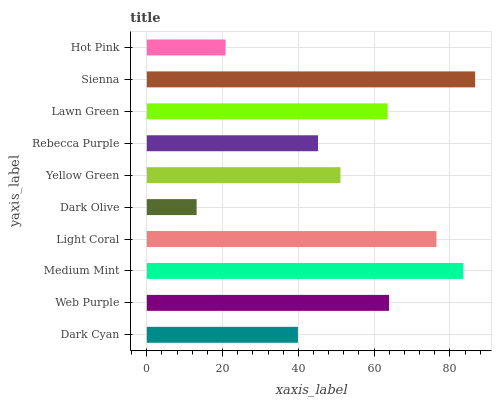Is Dark Olive the minimum?
Answer yes or no. Yes. Is Sienna the maximum?
Answer yes or no. Yes. Is Web Purple the minimum?
Answer yes or no. No. Is Web Purple the maximum?
Answer yes or no. No. Is Web Purple greater than Dark Cyan?
Answer yes or no. Yes. Is Dark Cyan less than Web Purple?
Answer yes or no. Yes. Is Dark Cyan greater than Web Purple?
Answer yes or no. No. Is Web Purple less than Dark Cyan?
Answer yes or no. No. Is Lawn Green the high median?
Answer yes or no. Yes. Is Yellow Green the low median?
Answer yes or no. Yes. Is Dark Olive the high median?
Answer yes or no. No. Is Hot Pink the low median?
Answer yes or no. No. 